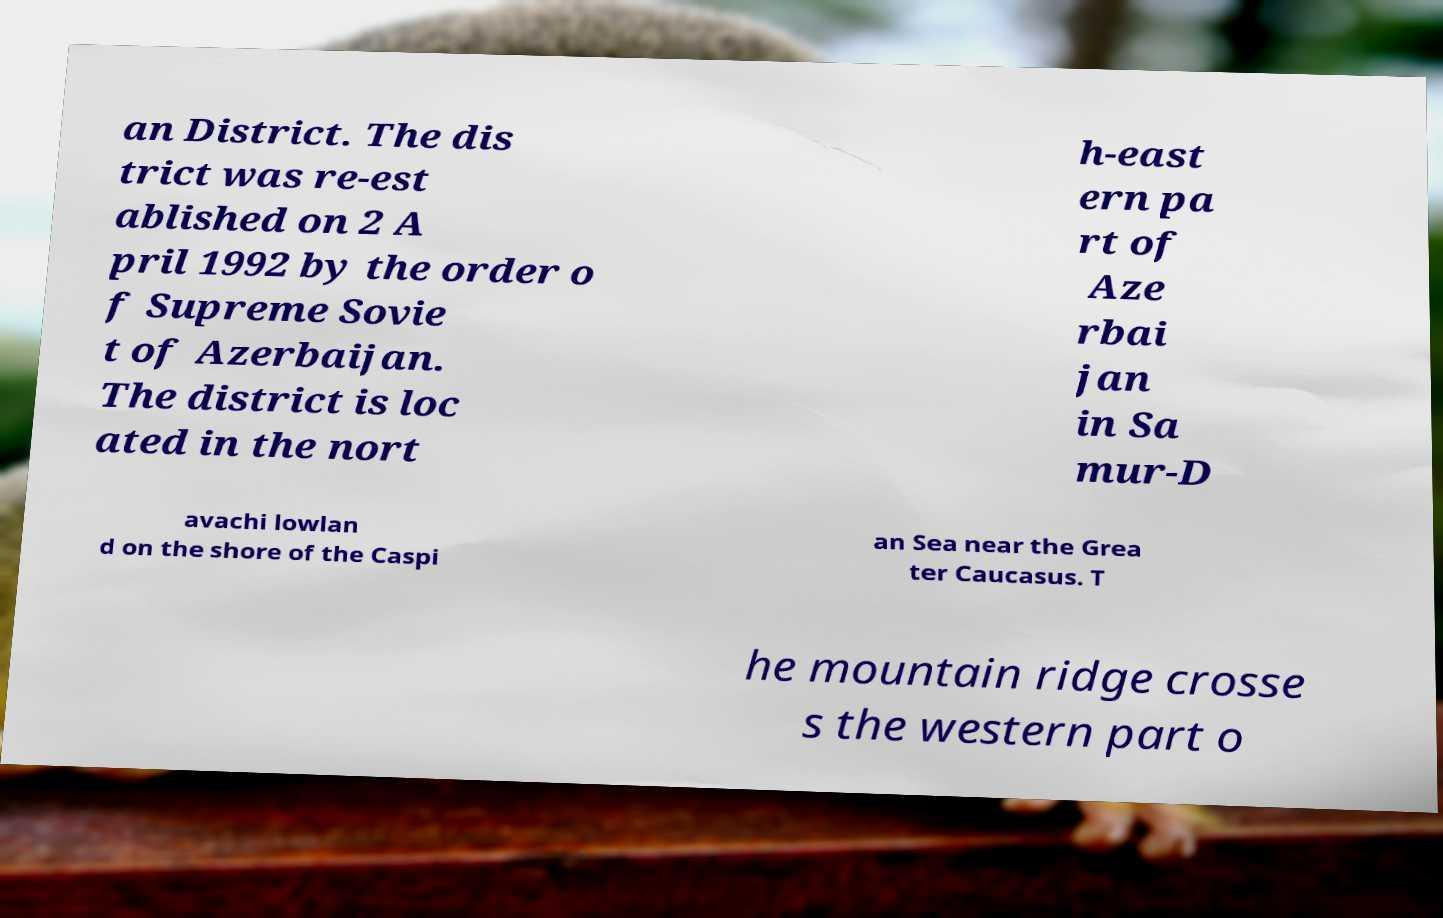What messages or text are displayed in this image? I need them in a readable, typed format. an District. The dis trict was re-est ablished on 2 A pril 1992 by the order o f Supreme Sovie t of Azerbaijan. The district is loc ated in the nort h-east ern pa rt of Aze rbai jan in Sa mur-D avachi lowlan d on the shore of the Caspi an Sea near the Grea ter Caucasus. T he mountain ridge crosse s the western part o 